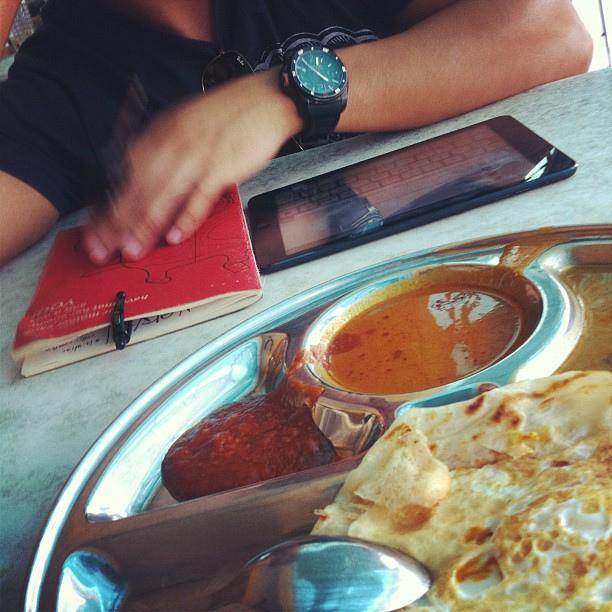What is the silver plate the man is using made of? metal 